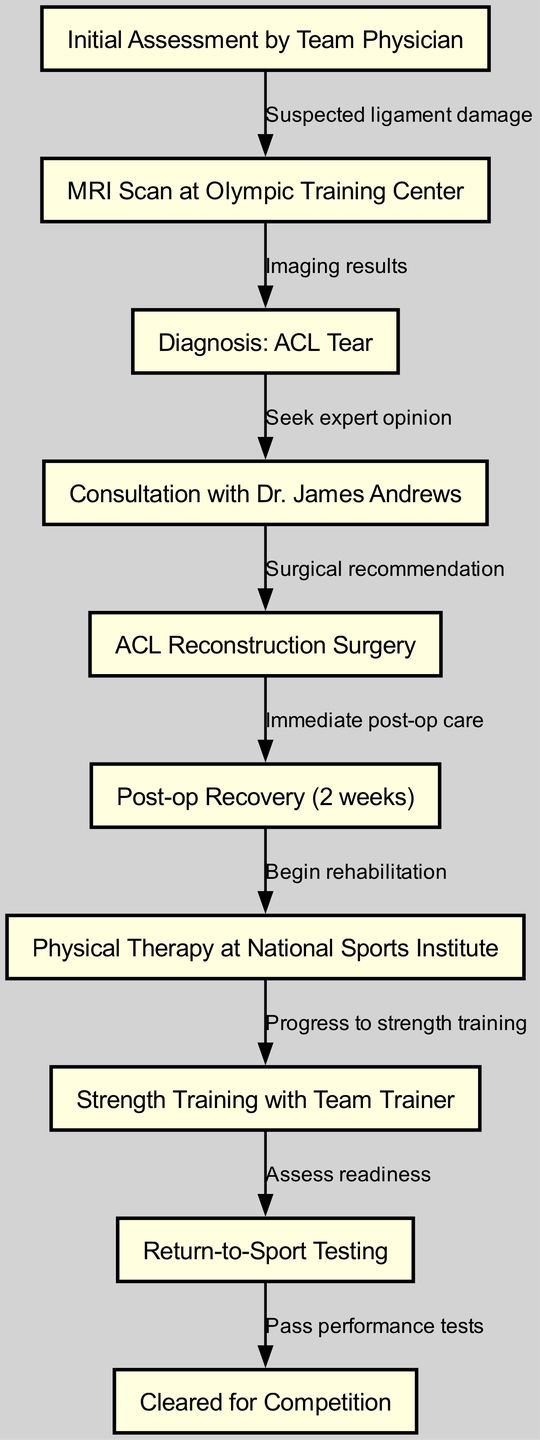What is the first step in the treatment pathway? The first step is the "Initial Assessment by Team Physician." It can be found as node 1 in the diagram, indicating the starting point of the clinical pathway for sports-related knee injuries.
Answer: Initial Assessment by Team Physician How many nodes are present in the diagram? By counting the elements in the "nodes" section of the provided data, we see there are a total of 10 distinct steps listed, indicating the various stages of the treatment pathway.
Answer: 10 What does the edge from "MRI Scan at Olympic Training Center" to "Diagnosis: ACL Tear" represent? This edge indicates the relationship where the results of the MRI scan lead to the diagnosis of an ACL tear. It's reflected in the diagram with the label "Imaging results," which explains the transition between these two stages.
Answer: Imaging results Who provides the surgical recommendation? The "Consultation with Dr. James Andrews" provides the surgical recommendation according to the diagram, moving from node 4 to node 5. The edge states "Surgical recommendation," linking expert consultation to the next step of surgery.
Answer: Dr. James Andrews What is the duration of post-operative recovery? The diagram specifies that the duration of post-op recovery is "2 weeks," as noted in node 6 of the pathway. This indicates the time frame allocated for initial recovery following ACL reconstruction surgery.
Answer: 2 weeks What is the last step before being cleared for competition? The last step before being cleared for competition is "Return-to-Sport Testing," which is linked to the final stage of "Cleared for Competition." This highlights the importance of performance testing before returning to athletic activities.
Answer: Return-to-Sport Testing Which node follows the "Post-op Recovery"? The node that follows "Post-op Recovery (2 weeks)" is "Physical Therapy at National Sports Institute." This sequence illustrates the progression from recovery to rehabilitation.
Answer: Physical Therapy at National Sports Institute What is the purpose of the strength training with the team trainer? The purpose of strength training with the team trainer, indicated in the diagram, is to "Progress to strength training," which is a crucial part of the rehabilitation pathway. This step emphasizes the importance of building strength after surgery.
Answer: Progress to strength training 